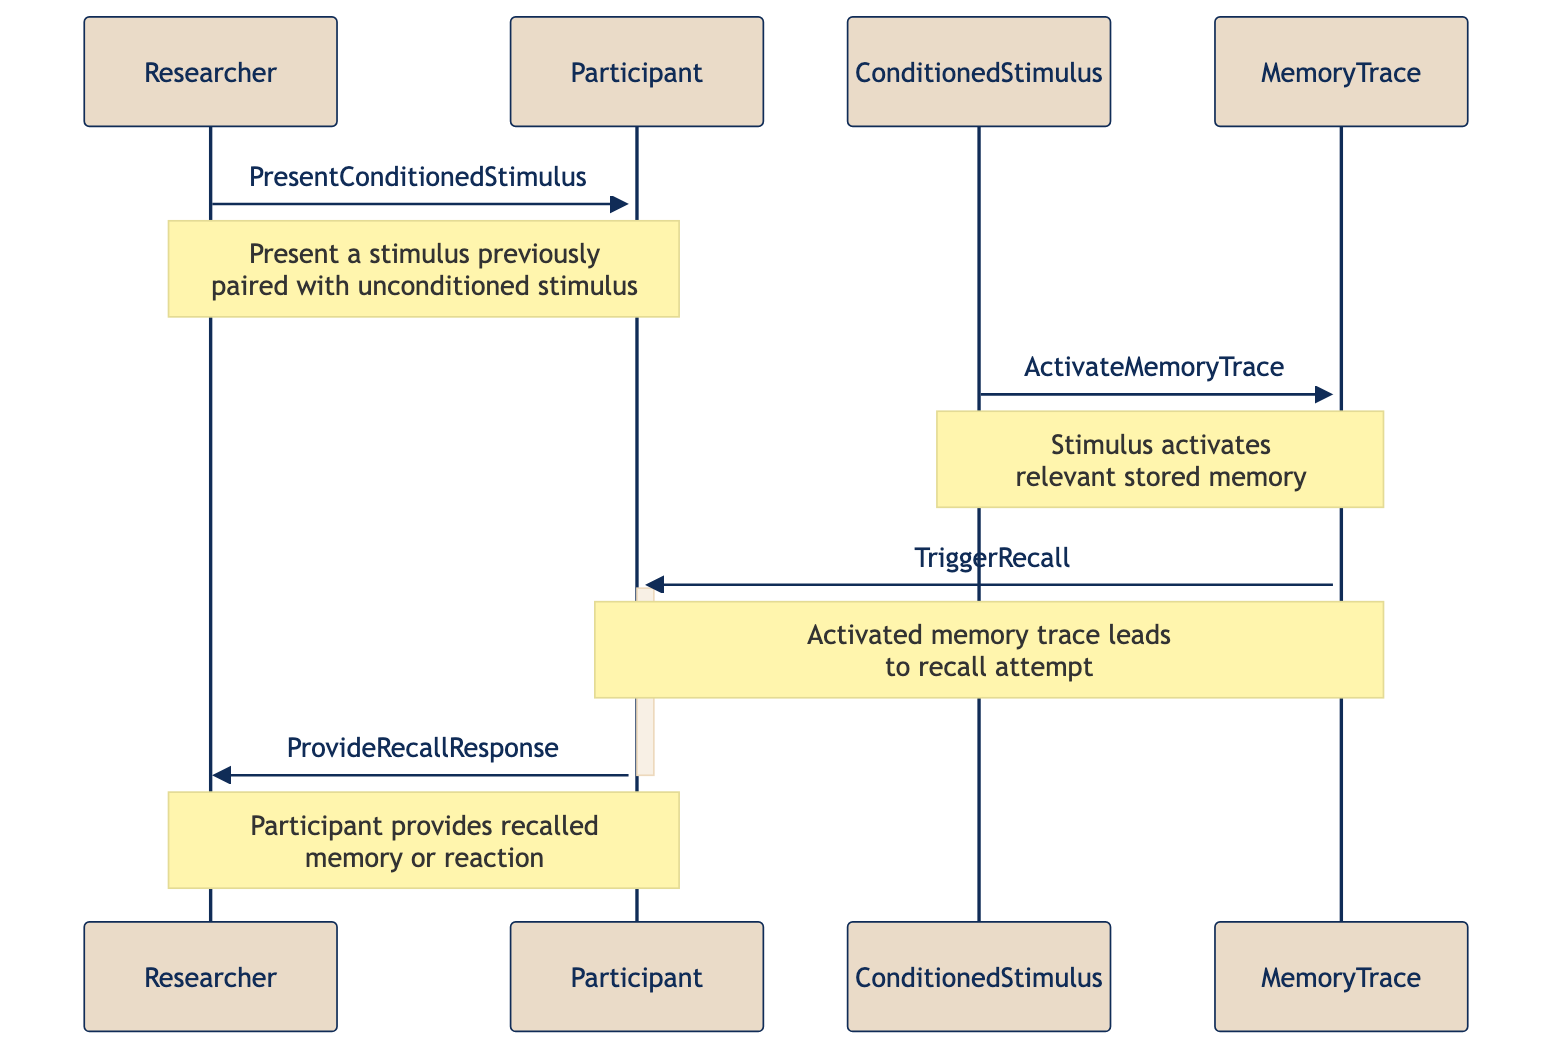What is the first action in the sequence? The first action in the sequence is taken by the Researcher, who presents the Conditioned Stimulus to the Participant. This is indicated by the message from Researcher to Participant labeled "PresentConditionedStimulus."
Answer: PresentConditionedStimulus Who receives the memory activation? The Conditioned Stimulus activates the Memory Trace, as seen in the interaction where the Conditioned Stimulus messages the Memory Trace with "ActivateMemoryTrace."
Answer: MemoryTrace How many participants are involved in the sequence? There are two participants in the sequence: the Researcher and the Participant. This is evident at the beginning of the diagram where both actors are defined.
Answer: Two What does the Memory Trace trigger? The Memory Trace triggers a recall attempt, which is shown by the message from Memory Trace to Participant labeled "TriggerRecall."
Answer: Recall attempt What does the Participant provide in the end? The Participant provides their recalled memory or reaction to the Researcher, as denoted by the message "ProvideRecallResponse."
Answer: Recalled memory What kind of stimulus is presented by the Researcher? The Researcher presents a Conditioned Stimulus, which is the type of stimulus discussed in the first message of the sequence diagram.
Answer: Conditioned Stimulus What does the Participant do after the Memory Trace is activated? After the Memory Trace is activated, the Participant attempts to recall the associated memory, as indicated by the "TriggerRecall" message from Memory Trace to Participant.
Answer: Attempts to recall What is the relationship between Conditioned Stimulus and Memory Trace? The Conditioned Stimulus activates the Memory Trace, which is shown by the connection from Conditioned Stimulus to Memory Trace marked "ActivateMemoryTrace."
Answer: Activates What action does the Researcher take after the Participant provides their recall response? The diagram does not depict any further action taken by the Researcher after the Participant provides their recall response, indicating the completion of this specific process.
Answer: None 